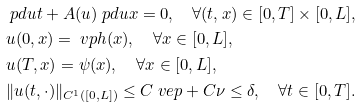<formula> <loc_0><loc_0><loc_500><loc_500>& \ p d u t + A ( u ) \ p d u x = 0 , \quad \forall ( t , x ) \in [ 0 , T ] \times [ 0 , L ] , \\ & u ( 0 , x ) = \ v p h ( x ) , \quad \forall x \in [ 0 , L ] , \\ & u ( T , x ) = \psi ( x ) , \quad \forall x \in [ 0 , L ] , \\ & \| u ( t , \cdot ) \| _ { C ^ { 1 } ( [ 0 , L ] ) } \leq C \ v e p + C \nu \leq \delta , \quad \forall t \in [ 0 , T ] .</formula> 